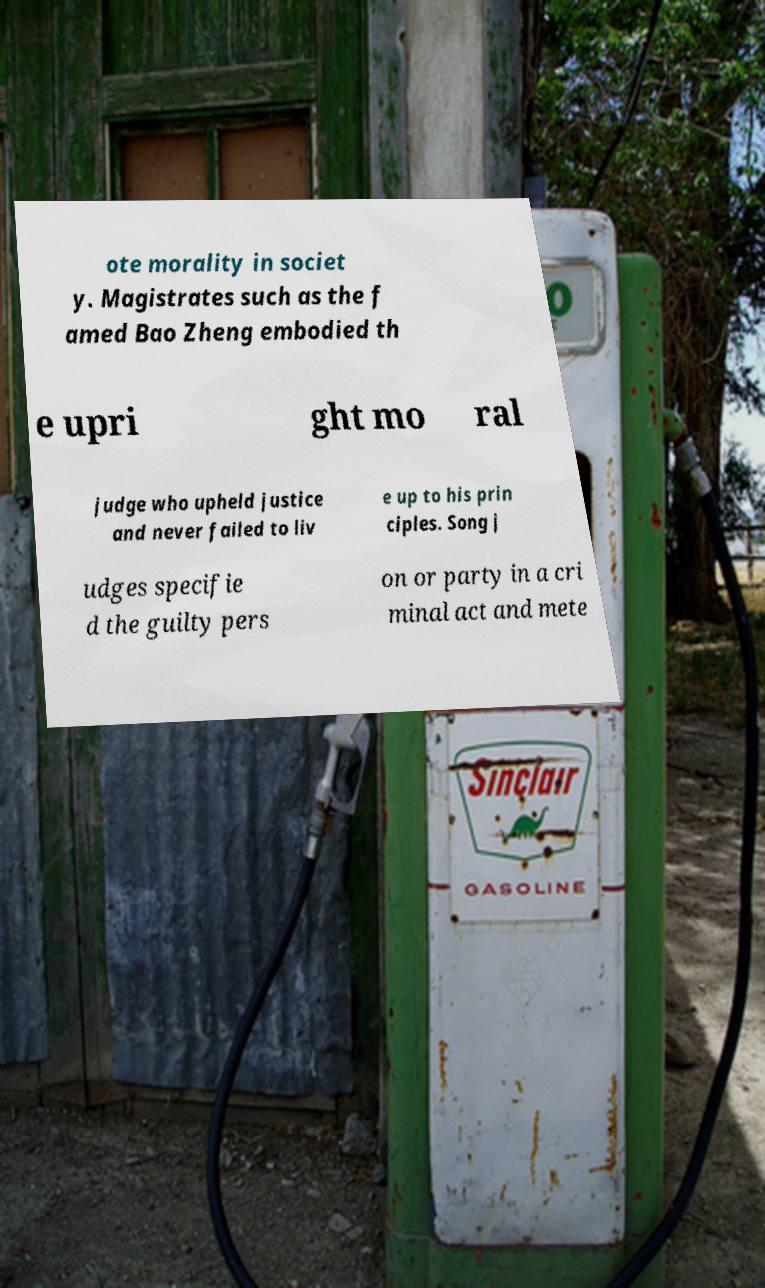Please read and relay the text visible in this image. What does it say? ote morality in societ y. Magistrates such as the f amed Bao Zheng embodied th e upri ght mo ral judge who upheld justice and never failed to liv e up to his prin ciples. Song j udges specifie d the guilty pers on or party in a cri minal act and mete 